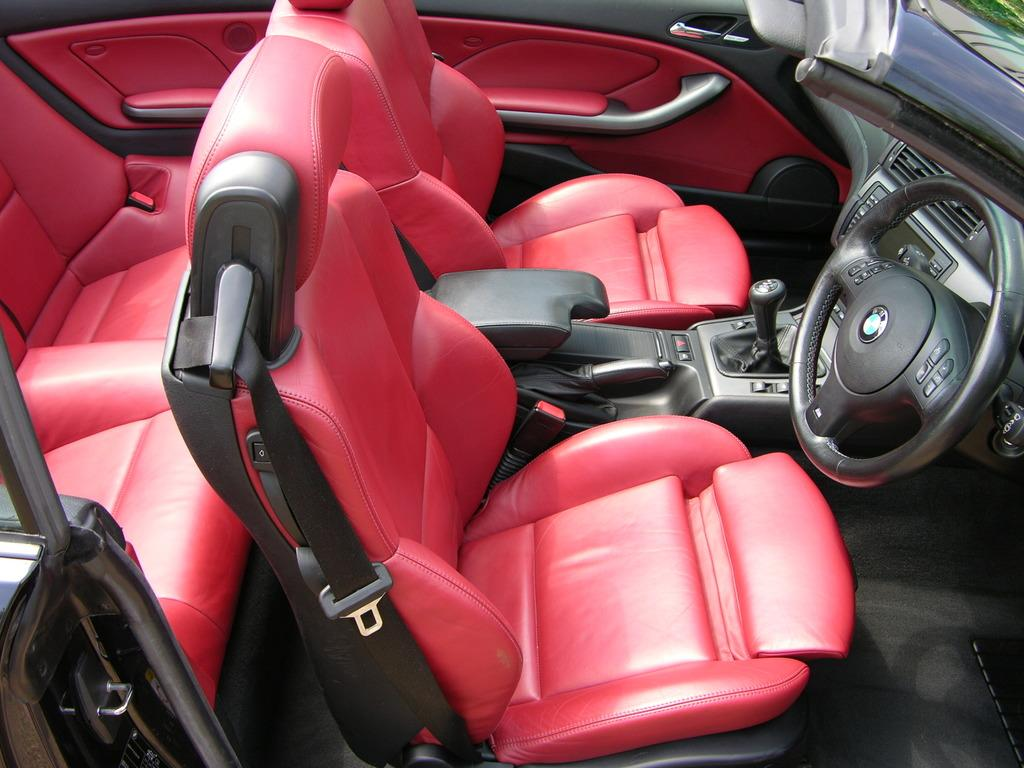What type of setting is depicted in the image? The image shows the interior of a vehicle. What type of work is being done on the sidewalk in the image? There is no sidewalk present in the image, as it shows the interior of a vehicle. 